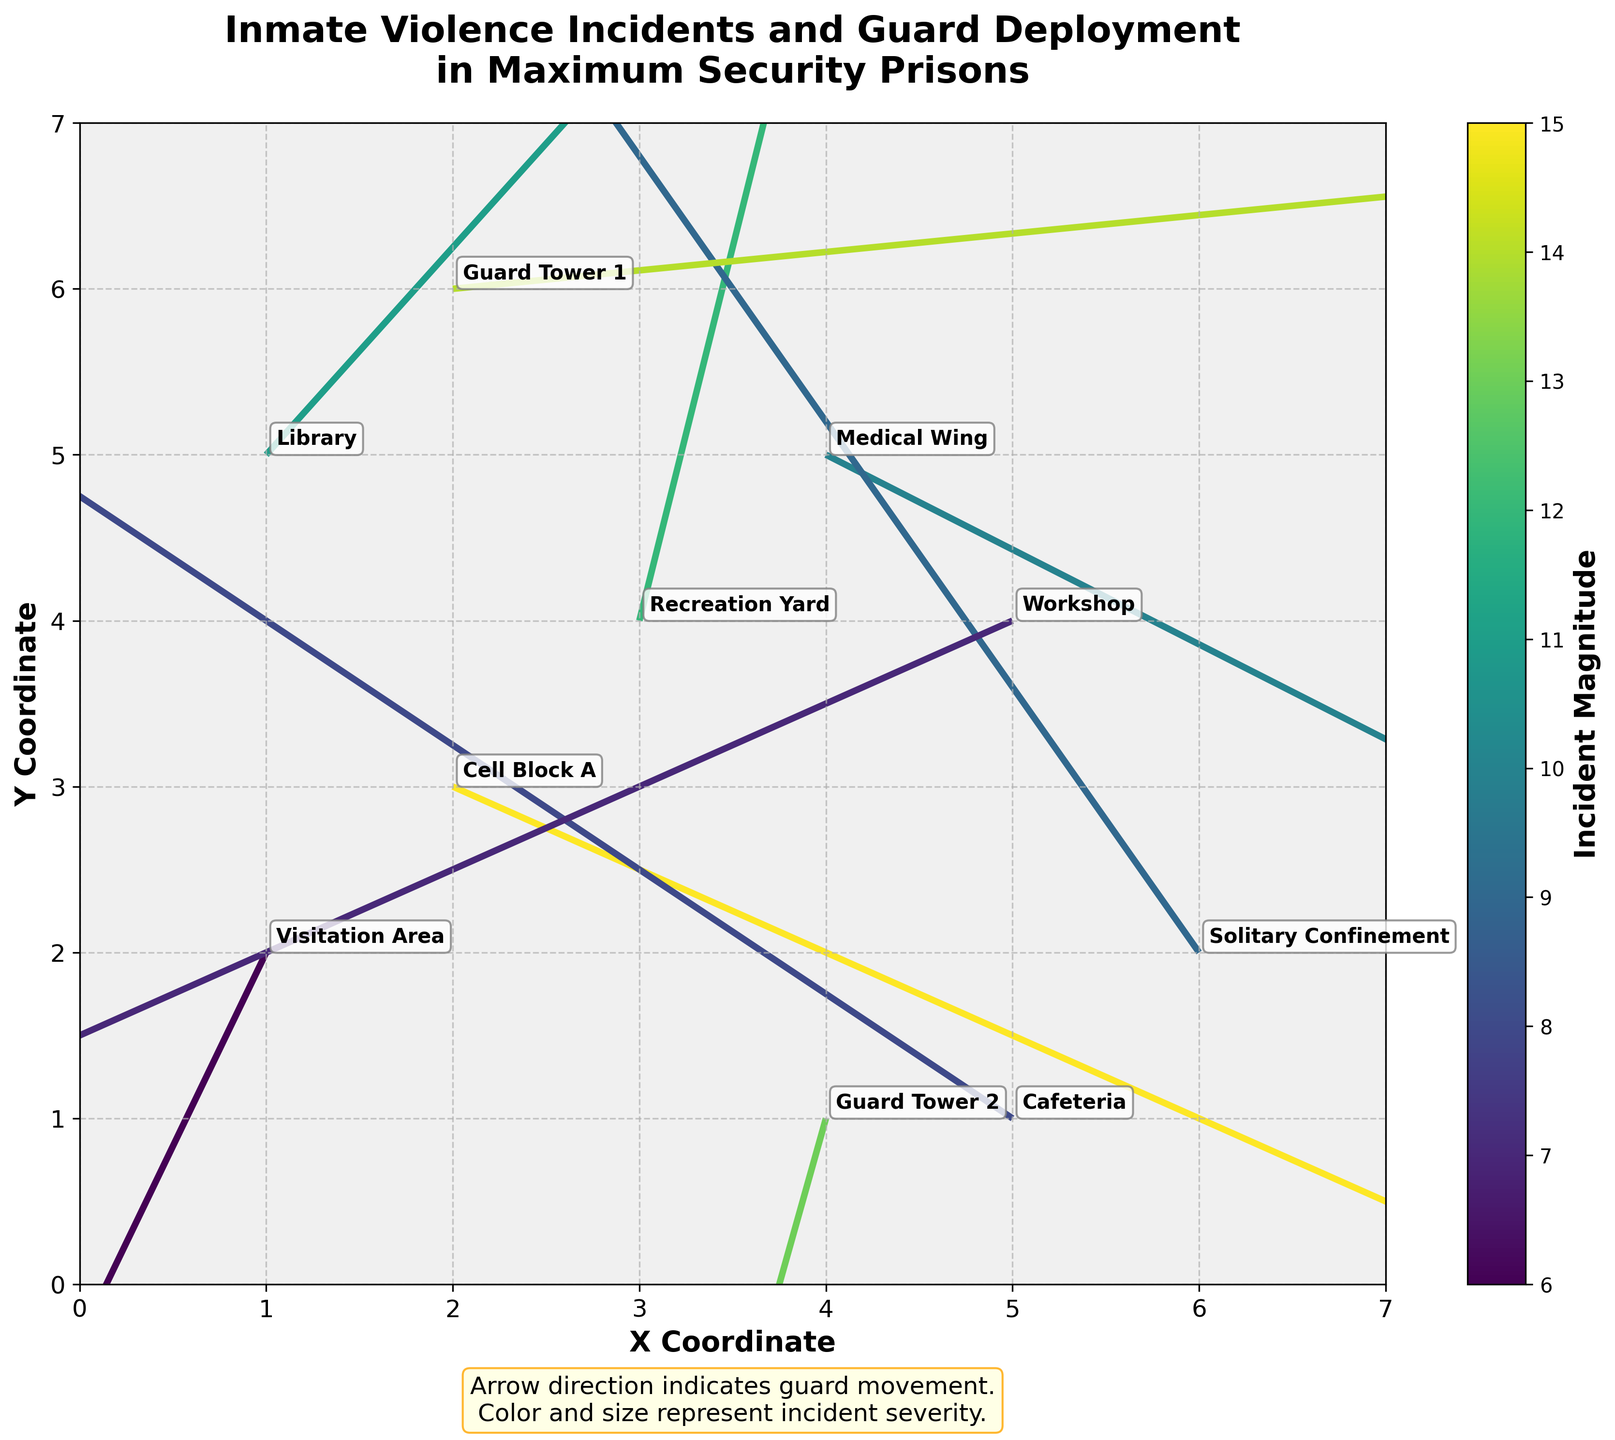How many locations are indicated on the plot? Count the number of distinct locations annotated on the plot. There are 10 locations mentioned in total.
Answer: 10 What is the title of the plot? The title of the plot is written at the top center and reads: "Inmate Violence Incidents and Guard Deployment in Maximum Security Prisons."
Answer: Inmate Violence Incidents and Guard Deployment in Maximum Security Prisons Which location shows the highest magnitude of incidents? Look at the colorbar and compare the color intensities for each arrow. The location with the vector arrow having the darkest color (largest magnitude) is Cell Block A (magnitude 15).
Answer: Cell Block A Which direction are the guards moving in the Library and Guard Tower 1? Check the vectors' directions originating from the Library (1,5) and Guard Tower 1 (2,6). The arrow in the Library is moving slightly upwards and towards the right (+0.4, +0.5), while the arrow at Guard Tower 1 is moving almost horizontally to the right (+0.9, +0.1).
Answer: Right-upwards for Library, Mostly rightwards for Guard Tower 1 How many vectors are pointing in the negative X direction? Vectors point in the negative X direction if their U component is negative. In this plot, -0.8 (Cafeteria), -0.3 (Visitation Area), -0.5 (Solitary Confinement), -0.6 (Workshop), and -0.2 (Guard Tower 2) are negative X directions.
Answer: 5 Which location has a guard moving with the most vertical (Y) displacement? Calculate U from the data list to see which vector has the greatest vertical displacement (V value), which is Cell Block A with a vertical displacement of -0.5 (absolute value accounts for most displacement).
Answer: Cell Block A Compare the magnitude of incidents in the Medical Wing and the Recreation Yard. Which is higher? The magnitude numbers provided show the Medical Wing with a magnitude of 10 and the Recreation Yard with a magnitude of 12. Therefore, the incidents are higher in the Recreation Yard.
Answer: Recreation Yard What are the coordinates of the Workshop? The coordinates are directly annotated for each location. The Workshop is at the coordinates (5, 4).
Answer: (5, 4) Which location has the smallest movement vector (U, V) combination? By comparing the magnitudes, which combine both U and V, the smallest magnitude belongs to the Visitation Area (magnitude 6).
Answer: Visitation Area 